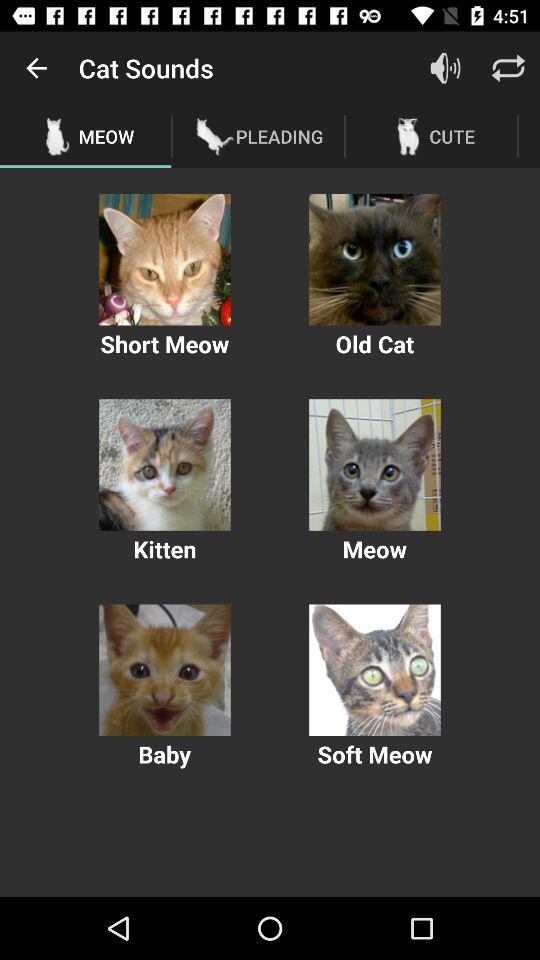What are the given options in "Cat Sounds"? The given options in "Cat Sounds" are "Short Meow", "Old Cat", "Kitten", "Meow", "Baby" and "Soft Meow". 